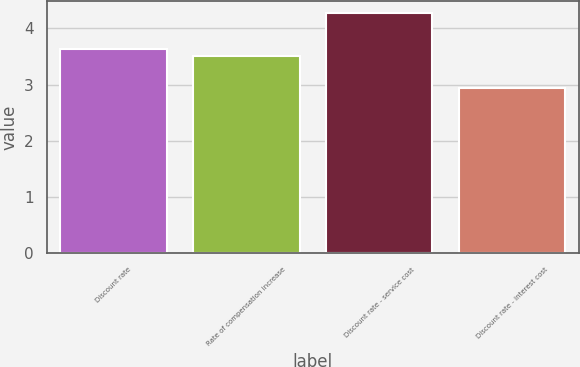Convert chart to OTSL. <chart><loc_0><loc_0><loc_500><loc_500><bar_chart><fcel>Discount rate<fcel>Rate of compensation increase<fcel>Discount rate - service cost<fcel>Discount rate - interest cost<nl><fcel>3.63<fcel>3.5<fcel>4.27<fcel>2.94<nl></chart> 